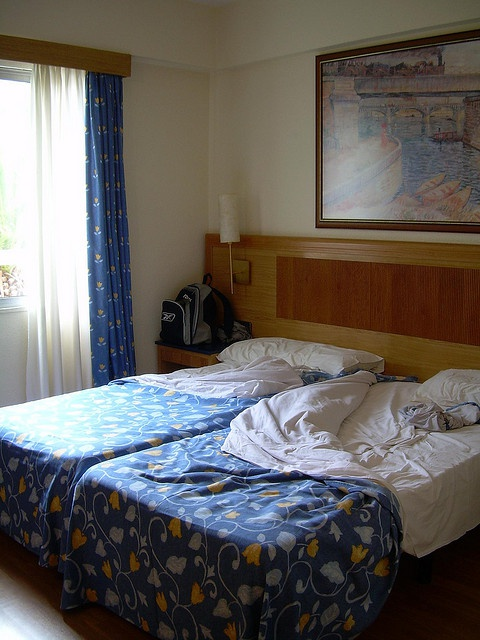Describe the objects in this image and their specific colors. I can see bed in gray, black, maroon, and lightblue tones and backpack in gray and black tones in this image. 